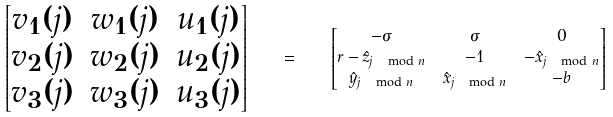<formula> <loc_0><loc_0><loc_500><loc_500>\begin{bmatrix} v _ { 1 } ( j ) & w _ { 1 } ( j ) & u _ { 1 } ( j ) \\ v _ { 2 } ( j ) & w _ { 2 } ( j ) & u _ { 2 } ( j ) \\ v _ { 3 } ( j ) & w _ { 3 } ( j ) & u _ { 3 } ( j ) \end{bmatrix} \quad = \quad & \begin{bmatrix} - \sigma & \sigma & 0 \\ r - \hat { z } _ { j \, \mod n } & - 1 & - \hat { x } _ { j \, \mod n } \\ \hat { y } _ { j \, \mod n } & \hat { x } _ { j \, \mod n } & - b \end{bmatrix}</formula> 